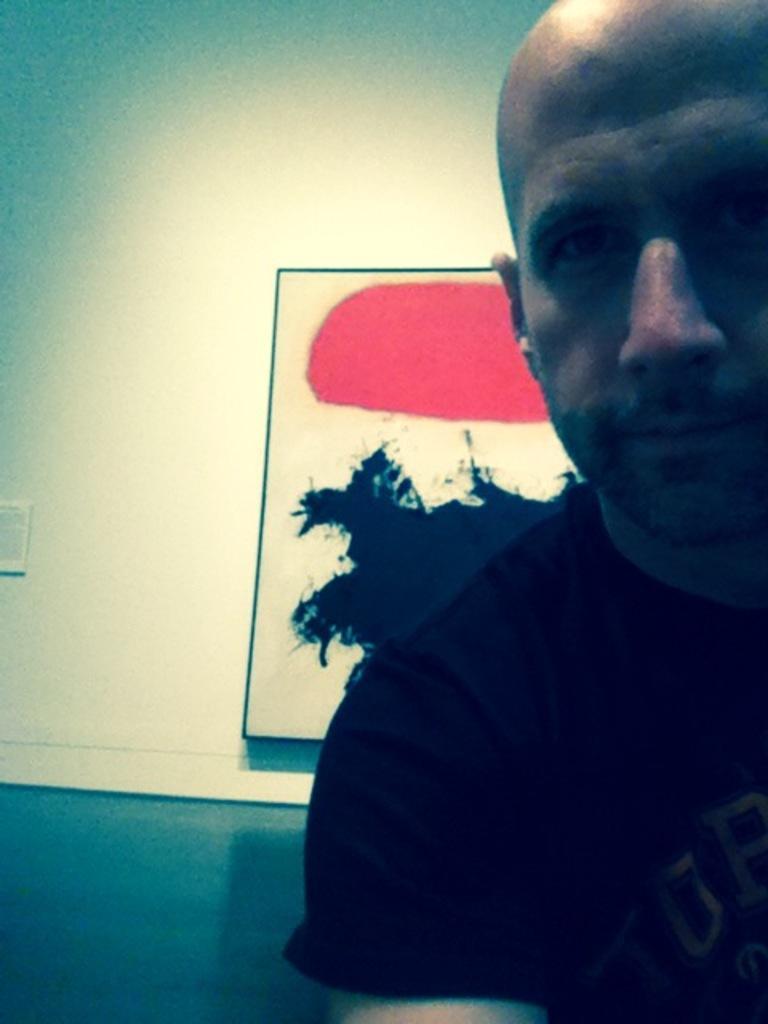Please provide a concise description of this image. In this image I can see a person wearing a black color shirt and at the top I can see the wall and photo frame attached to the wall. 